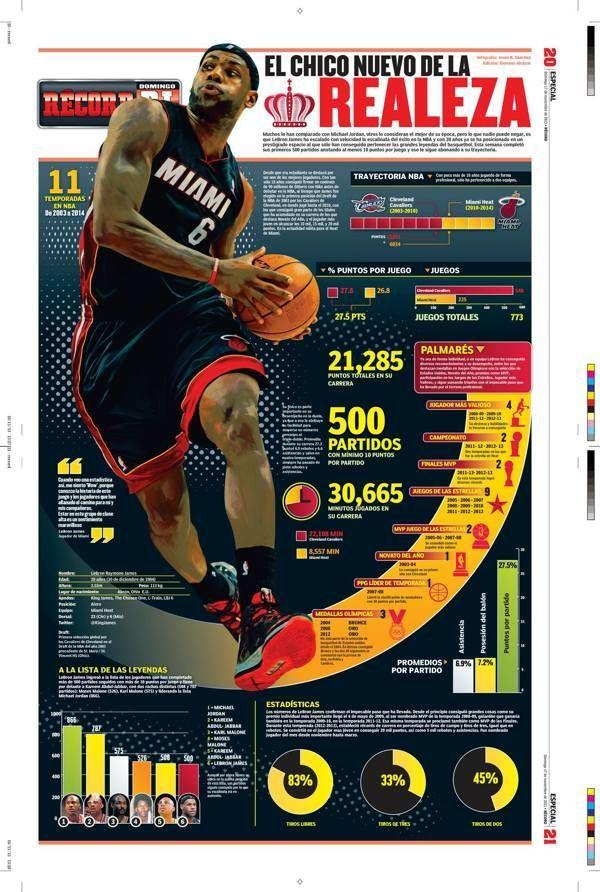what team name is written on the T shirt
Answer the question with a short phrase. MIAMI What number is written on the T shirt 6 